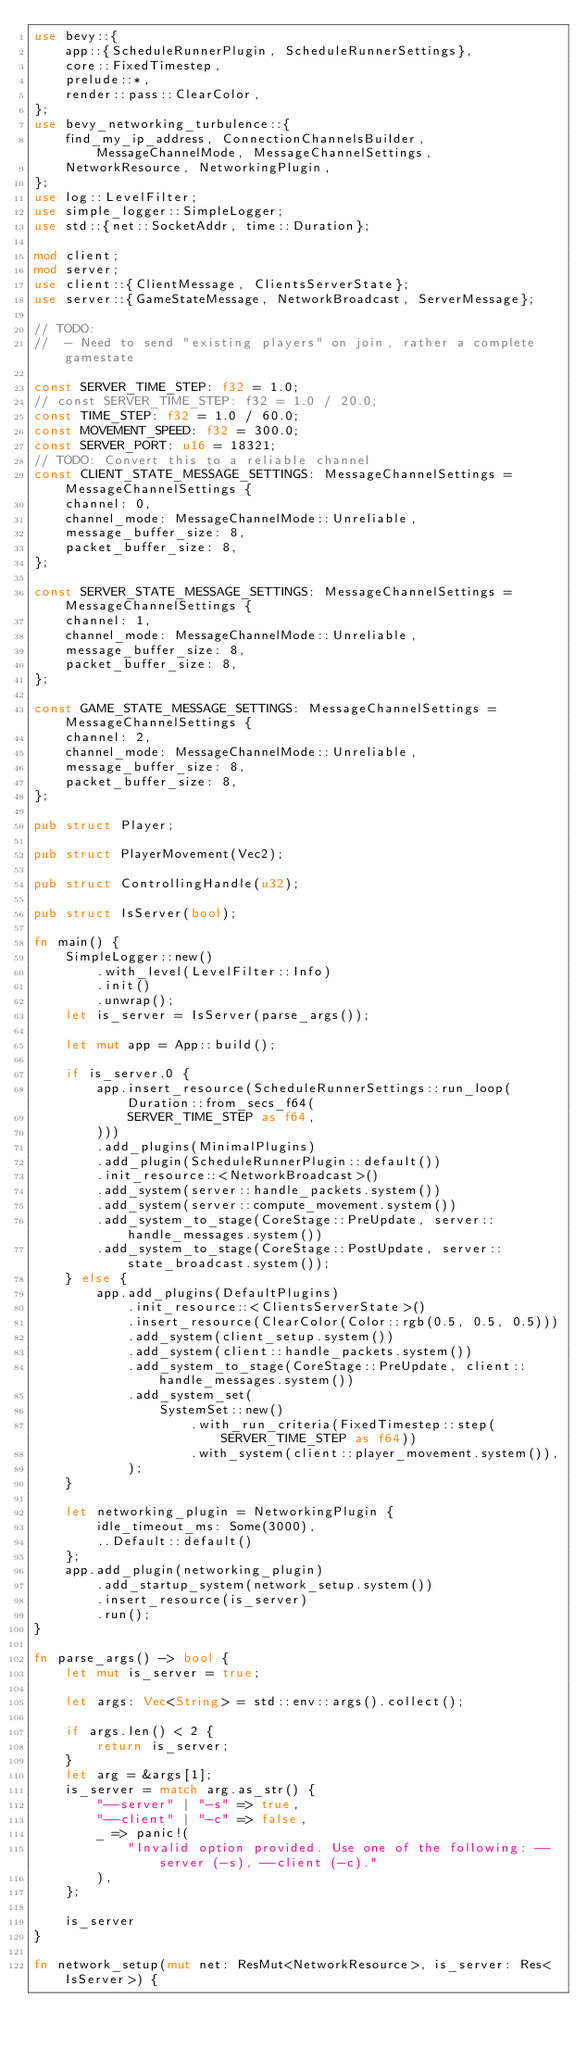<code> <loc_0><loc_0><loc_500><loc_500><_Rust_>use bevy::{
    app::{ScheduleRunnerPlugin, ScheduleRunnerSettings},
    core::FixedTimestep,
    prelude::*,
    render::pass::ClearColor,
};
use bevy_networking_turbulence::{
    find_my_ip_address, ConnectionChannelsBuilder, MessageChannelMode, MessageChannelSettings,
    NetworkResource, NetworkingPlugin,
};
use log::LevelFilter;
use simple_logger::SimpleLogger;
use std::{net::SocketAddr, time::Duration};

mod client;
mod server;
use client::{ClientMessage, ClientsServerState};
use server::{GameStateMessage, NetworkBroadcast, ServerMessage};

// TODO:
//  - Need to send "existing players" on join, rather a complete gamestate

const SERVER_TIME_STEP: f32 = 1.0;
// const SERVER_TIME_STEP: f32 = 1.0 / 20.0;
const TIME_STEP: f32 = 1.0 / 60.0;
const MOVEMENT_SPEED: f32 = 300.0;
const SERVER_PORT: u16 = 18321;
// TODO: Convert this to a reliable channel
const CLIENT_STATE_MESSAGE_SETTINGS: MessageChannelSettings = MessageChannelSettings {
    channel: 0,
    channel_mode: MessageChannelMode::Unreliable,
    message_buffer_size: 8,
    packet_buffer_size: 8,
};

const SERVER_STATE_MESSAGE_SETTINGS: MessageChannelSettings = MessageChannelSettings {
    channel: 1,
    channel_mode: MessageChannelMode::Unreliable,
    message_buffer_size: 8,
    packet_buffer_size: 8,
};

const GAME_STATE_MESSAGE_SETTINGS: MessageChannelSettings = MessageChannelSettings {
    channel: 2,
    channel_mode: MessageChannelMode::Unreliable,
    message_buffer_size: 8,
    packet_buffer_size: 8,
};

pub struct Player;

pub struct PlayerMovement(Vec2);

pub struct ControllingHandle(u32);

pub struct IsServer(bool);

fn main() {
    SimpleLogger::new()
        .with_level(LevelFilter::Info)
        .init()
        .unwrap();
    let is_server = IsServer(parse_args());

    let mut app = App::build();

    if is_server.0 {
        app.insert_resource(ScheduleRunnerSettings::run_loop(Duration::from_secs_f64(
            SERVER_TIME_STEP as f64,
        )))
        .add_plugins(MinimalPlugins)
        .add_plugin(ScheduleRunnerPlugin::default())
        .init_resource::<NetworkBroadcast>()
        .add_system(server::handle_packets.system())
        .add_system(server::compute_movement.system())
        .add_system_to_stage(CoreStage::PreUpdate, server::handle_messages.system())
        .add_system_to_stage(CoreStage::PostUpdate, server::state_broadcast.system());
    } else {
        app.add_plugins(DefaultPlugins)
            .init_resource::<ClientsServerState>()
            .insert_resource(ClearColor(Color::rgb(0.5, 0.5, 0.5)))
            .add_system(client_setup.system())
            .add_system(client::handle_packets.system())
            .add_system_to_stage(CoreStage::PreUpdate, client::handle_messages.system())
            .add_system_set(
                SystemSet::new()
                    .with_run_criteria(FixedTimestep::step(SERVER_TIME_STEP as f64))
                    .with_system(client::player_movement.system()),
            );
    }

    let networking_plugin = NetworkingPlugin {
        idle_timeout_ms: Some(3000),
        ..Default::default()
    };
    app.add_plugin(networking_plugin)
        .add_startup_system(network_setup.system())
        .insert_resource(is_server)
        .run();
}

fn parse_args() -> bool {
    let mut is_server = true;

    let args: Vec<String> = std::env::args().collect();

    if args.len() < 2 {
        return is_server;
    }
    let arg = &args[1];
    is_server = match arg.as_str() {
        "--server" | "-s" => true,
        "--client" | "-c" => false,
        _ => panic!(
            "Invalid option provided. Use one of the following: --server (-s), --client (-c)."
        ),
    };

    is_server
}

fn network_setup(mut net: ResMut<NetworkResource>, is_server: Res<IsServer>) {</code> 